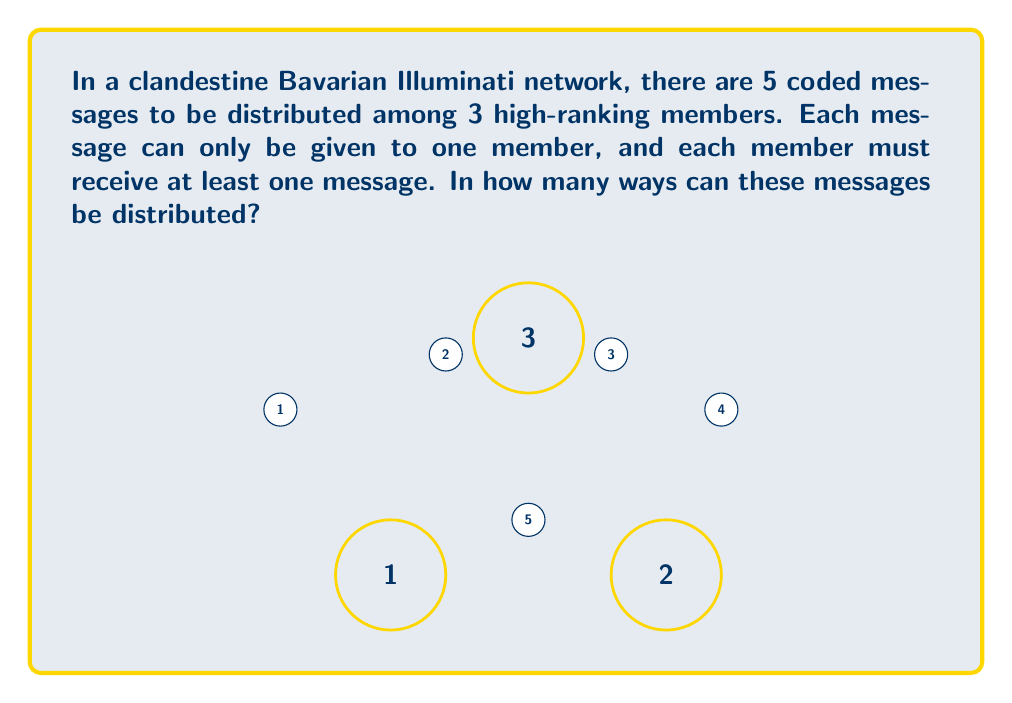Provide a solution to this math problem. To solve this problem, we can use the concept of Stirling numbers of the second kind and the principle of inclusion-exclusion.

1) First, let's consider the total number of ways to distribute 5 messages to 3 members without restrictions. This would be $3^5 = 243$.

2) However, we need to exclude cases where one or more members receive no messages. Let's use the principle of inclusion-exclusion:

   Let $A_i$ be the set of distributions where member $i$ receives no messages.

3) We need to calculate:
   $$|A_1 \cup A_2 \cup A_3| = |A_1| + |A_2| + |A_3| - |A_1 \cap A_2| - |A_1 \cap A_3| - |A_2 \cap A_3| + |A_1 \cap A_2 \cap A_3|$$

4) $|A_1| = |A_2| = |A_3| = 2^5 = 32$ (ways to distribute 5 messages to 2 members)
   $|A_1 \cap A_2| = |A_1 \cap A_3| = |A_2 \cap A_3| = 1^5 = 1$ (ways to distribute 5 messages to 1 member)
   $|A_1 \cap A_2 \cap A_3| = 0$ (can't give no messages to all members)

5) Substituting:
   $|A_1 \cup A_2 \cup A_3| = 32 + 32 + 32 - 1 - 1 - 1 + 0 = 93$

6) Therefore, the number of valid distributions is:
   $3^5 - 93 = 243 - 93 = 150$

This result corresponds to the Stirling number of the second kind $\stirling{5}{3}$, which represents the number of ways to partition a set of 5 elements into 3 non-empty subsets.
Answer: 150 